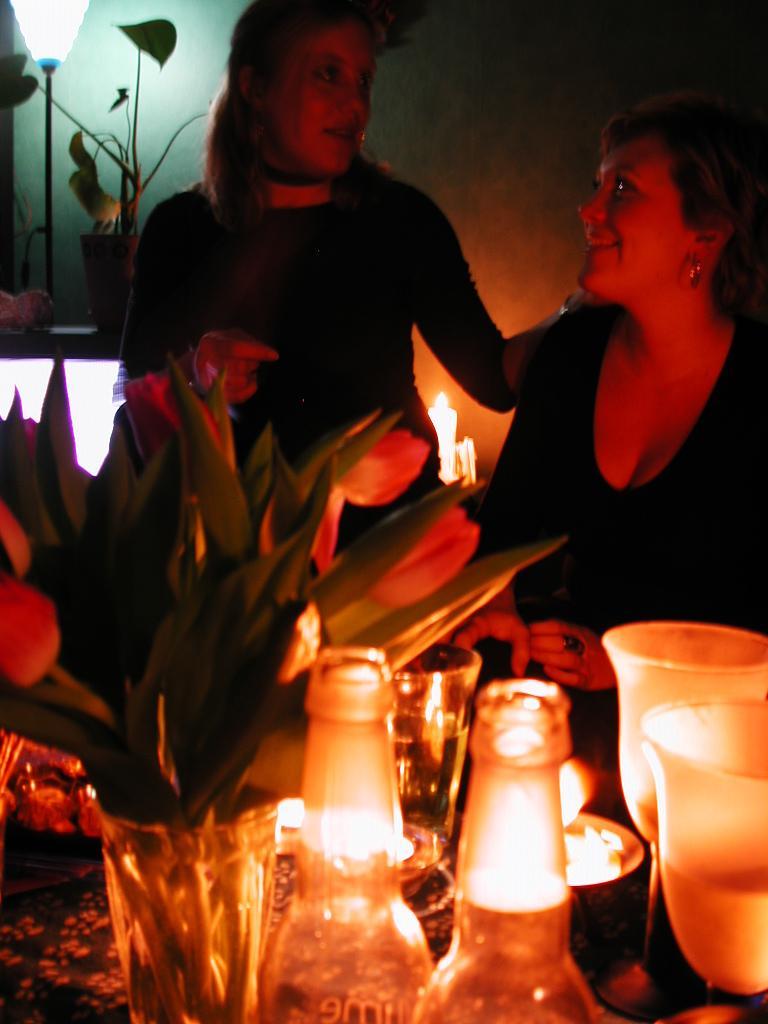How would you summarize this image in a sentence or two? In this picture we can see two woman talking to each other and smiling and in front of them we can see vase with flower in it,bottles, glasses and in background we can see wall. 